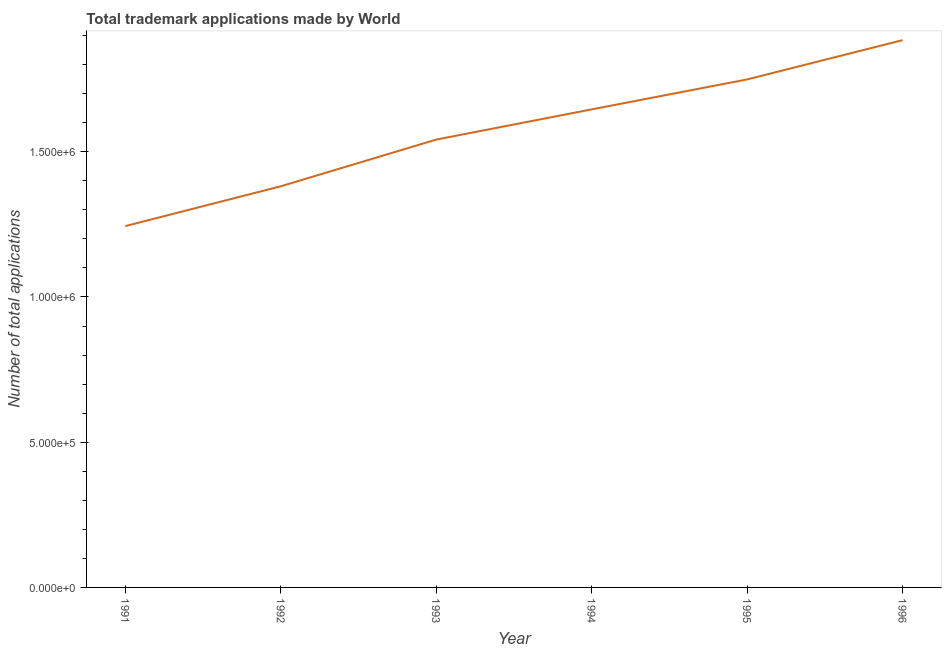What is the number of trademark applications in 1994?
Your answer should be compact. 1.65e+06. Across all years, what is the maximum number of trademark applications?
Offer a terse response. 1.88e+06. Across all years, what is the minimum number of trademark applications?
Ensure brevity in your answer.  1.24e+06. In which year was the number of trademark applications minimum?
Provide a succinct answer. 1991. What is the sum of the number of trademark applications?
Ensure brevity in your answer.  9.45e+06. What is the difference between the number of trademark applications in 1991 and 1996?
Give a very brief answer. -6.40e+05. What is the average number of trademark applications per year?
Offer a terse response. 1.57e+06. What is the median number of trademark applications?
Offer a terse response. 1.59e+06. What is the ratio of the number of trademark applications in 1993 to that in 1994?
Your response must be concise. 0.94. Is the difference between the number of trademark applications in 1992 and 1994 greater than the difference between any two years?
Your answer should be compact. No. What is the difference between the highest and the second highest number of trademark applications?
Your answer should be compact. 1.35e+05. Is the sum of the number of trademark applications in 1992 and 1994 greater than the maximum number of trademark applications across all years?
Your response must be concise. Yes. What is the difference between the highest and the lowest number of trademark applications?
Provide a succinct answer. 6.40e+05. In how many years, is the number of trademark applications greater than the average number of trademark applications taken over all years?
Your answer should be very brief. 3. How many lines are there?
Ensure brevity in your answer.  1. What is the difference between two consecutive major ticks on the Y-axis?
Your response must be concise. 5.00e+05. What is the title of the graph?
Offer a terse response. Total trademark applications made by World. What is the label or title of the Y-axis?
Provide a short and direct response. Number of total applications. What is the Number of total applications of 1991?
Give a very brief answer. 1.24e+06. What is the Number of total applications of 1992?
Ensure brevity in your answer.  1.38e+06. What is the Number of total applications of 1993?
Keep it short and to the point. 1.54e+06. What is the Number of total applications of 1994?
Provide a succinct answer. 1.65e+06. What is the Number of total applications of 1995?
Provide a succinct answer. 1.75e+06. What is the Number of total applications in 1996?
Offer a very short reply. 1.88e+06. What is the difference between the Number of total applications in 1991 and 1992?
Ensure brevity in your answer.  -1.37e+05. What is the difference between the Number of total applications in 1991 and 1993?
Your answer should be very brief. -2.98e+05. What is the difference between the Number of total applications in 1991 and 1994?
Give a very brief answer. -4.02e+05. What is the difference between the Number of total applications in 1991 and 1995?
Provide a succinct answer. -5.05e+05. What is the difference between the Number of total applications in 1991 and 1996?
Your response must be concise. -6.40e+05. What is the difference between the Number of total applications in 1992 and 1993?
Make the answer very short. -1.61e+05. What is the difference between the Number of total applications in 1992 and 1994?
Offer a very short reply. -2.65e+05. What is the difference between the Number of total applications in 1992 and 1995?
Ensure brevity in your answer.  -3.68e+05. What is the difference between the Number of total applications in 1992 and 1996?
Your response must be concise. -5.03e+05. What is the difference between the Number of total applications in 1993 and 1994?
Offer a very short reply. -1.04e+05. What is the difference between the Number of total applications in 1993 and 1995?
Keep it short and to the point. -2.07e+05. What is the difference between the Number of total applications in 1993 and 1996?
Your answer should be very brief. -3.42e+05. What is the difference between the Number of total applications in 1994 and 1995?
Keep it short and to the point. -1.03e+05. What is the difference between the Number of total applications in 1994 and 1996?
Give a very brief answer. -2.38e+05. What is the difference between the Number of total applications in 1995 and 1996?
Offer a very short reply. -1.35e+05. What is the ratio of the Number of total applications in 1991 to that in 1992?
Provide a short and direct response. 0.9. What is the ratio of the Number of total applications in 1991 to that in 1993?
Your answer should be compact. 0.81. What is the ratio of the Number of total applications in 1991 to that in 1994?
Give a very brief answer. 0.76. What is the ratio of the Number of total applications in 1991 to that in 1995?
Provide a succinct answer. 0.71. What is the ratio of the Number of total applications in 1991 to that in 1996?
Give a very brief answer. 0.66. What is the ratio of the Number of total applications in 1992 to that in 1993?
Give a very brief answer. 0.9. What is the ratio of the Number of total applications in 1992 to that in 1994?
Offer a terse response. 0.84. What is the ratio of the Number of total applications in 1992 to that in 1995?
Provide a succinct answer. 0.79. What is the ratio of the Number of total applications in 1992 to that in 1996?
Offer a very short reply. 0.73. What is the ratio of the Number of total applications in 1993 to that in 1994?
Offer a very short reply. 0.94. What is the ratio of the Number of total applications in 1993 to that in 1995?
Offer a very short reply. 0.88. What is the ratio of the Number of total applications in 1993 to that in 1996?
Make the answer very short. 0.82. What is the ratio of the Number of total applications in 1994 to that in 1995?
Your answer should be very brief. 0.94. What is the ratio of the Number of total applications in 1994 to that in 1996?
Ensure brevity in your answer.  0.87. What is the ratio of the Number of total applications in 1995 to that in 1996?
Your answer should be compact. 0.93. 